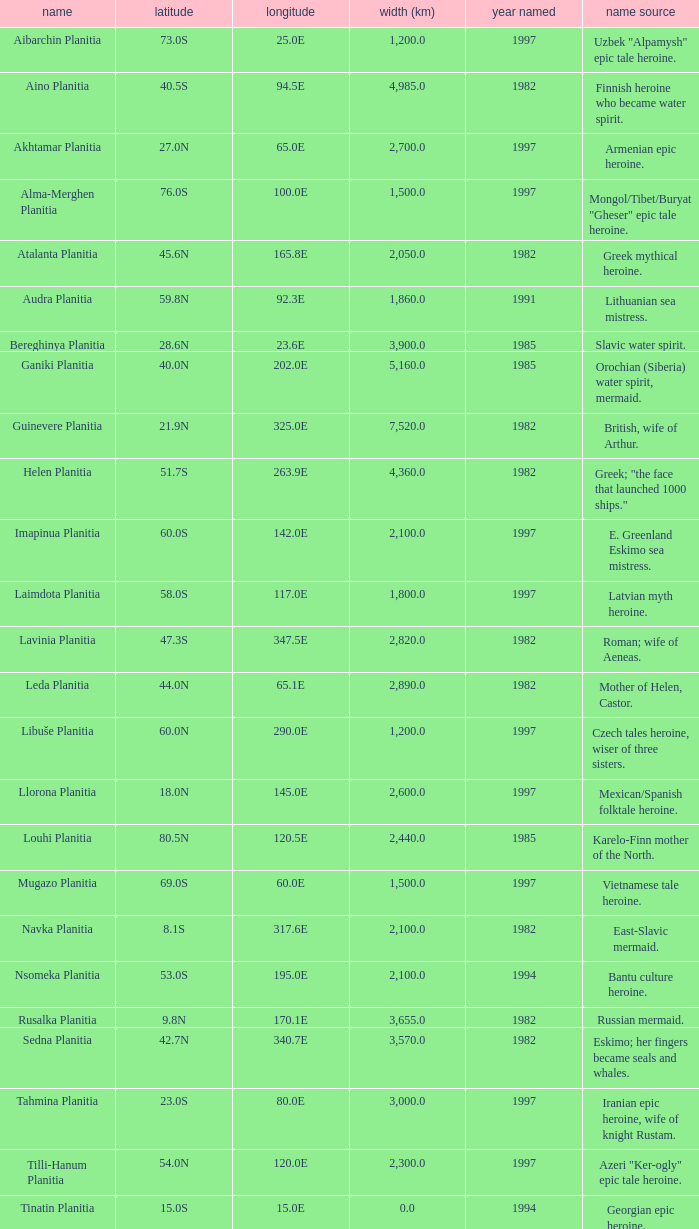What is the diameter (km) of the feature of latitude 23.0s 3000.0. 